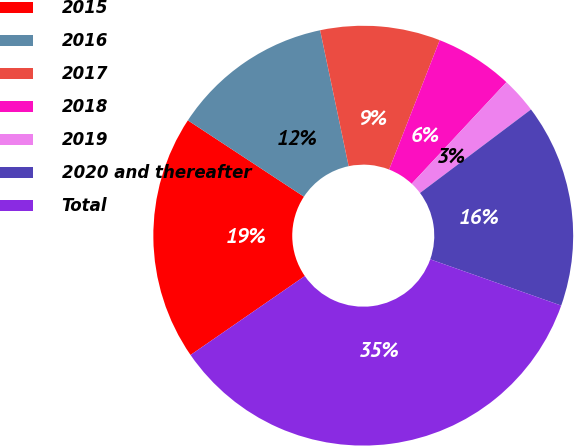Convert chart. <chart><loc_0><loc_0><loc_500><loc_500><pie_chart><fcel>2015<fcel>2016<fcel>2017<fcel>2018<fcel>2019<fcel>2020 and thereafter<fcel>Total<nl><fcel>18.88%<fcel>12.45%<fcel>9.23%<fcel>6.01%<fcel>2.79%<fcel>15.67%<fcel>34.98%<nl></chart> 